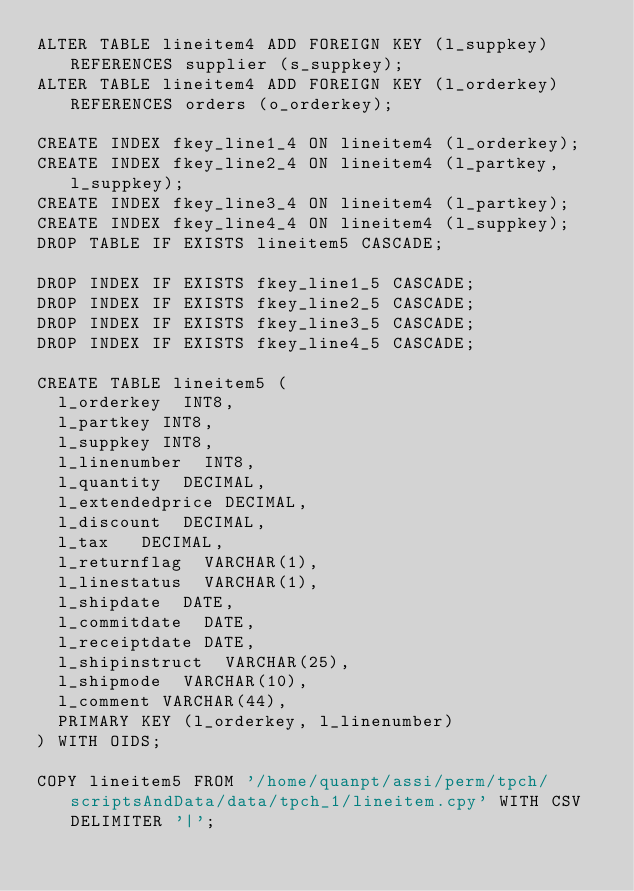<code> <loc_0><loc_0><loc_500><loc_500><_SQL_>ALTER TABLE lineitem4 ADD FOREIGN KEY (l_suppkey) REFERENCES supplier (s_suppkey);
ALTER TABLE lineitem4 ADD FOREIGN KEY (l_orderkey) REFERENCES orders (o_orderkey);

CREATE INDEX fkey_line1_4 ON lineitem4 (l_orderkey);
CREATE INDEX fkey_line2_4 ON lineitem4 (l_partkey, l_suppkey);
CREATE INDEX fkey_line3_4 ON lineitem4 (l_partkey);
CREATE INDEX fkey_line4_4 ON lineitem4 (l_suppkey);
DROP TABLE IF EXISTS lineitem5 CASCADE;

DROP INDEX IF EXISTS fkey_line1_5 CASCADE;
DROP INDEX IF EXISTS fkey_line2_5 CASCADE;
DROP INDEX IF EXISTS fkey_line3_5 CASCADE;
DROP INDEX IF EXISTS fkey_line4_5 CASCADE;

CREATE TABLE lineitem5 (
	l_orderkey	INT8,
	l_partkey	INT8,
	l_suppkey	INT8,
	l_linenumber	INT8,
	l_quantity	DECIMAL,
	l_extendedprice	DECIMAL,
	l_discount	DECIMAL,
	l_tax		DECIMAL,
	l_returnflag	VARCHAR(1),
	l_linestatus	VARCHAR(1),
	l_shipdate	DATE,
	l_commitdate	DATE,
	l_receiptdate	DATE,
	l_shipinstruct	VARCHAR(25),
	l_shipmode	VARCHAR(10),
	l_comment	VARCHAR(44),
	PRIMARY KEY (l_orderkey, l_linenumber)
) WITH OIDS;

COPY lineitem5 FROM '/home/quanpt/assi/perm/tpch/scriptsAndData/data/tpch_1/lineitem.cpy' WITH CSV DELIMITER '|';       
</code> 